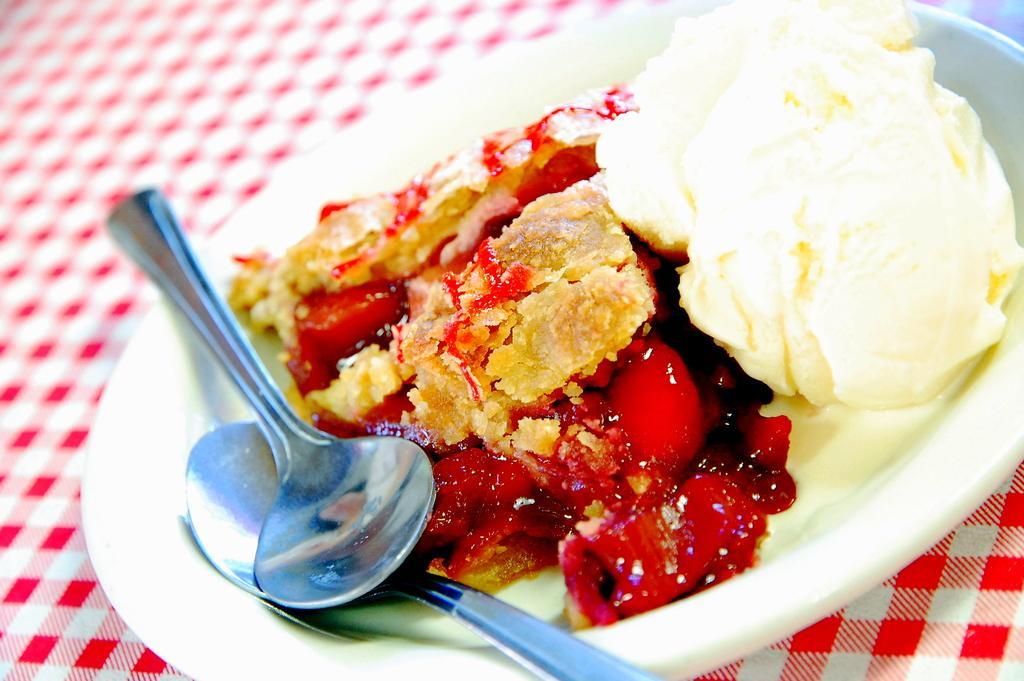Can you describe this image briefly? In the picture we can see a table with a table cloth and a plate on it which is white in color with some ice cream and some fruit garnish and two spoons in it. 